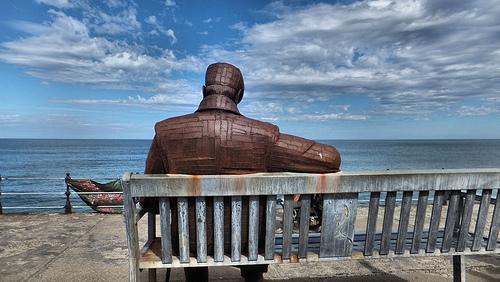How many statues are in the photo?
Give a very brief answer. 1. 